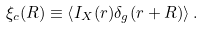Convert formula to latex. <formula><loc_0><loc_0><loc_500><loc_500>\xi _ { c } ( R ) \equiv \left < I _ { X } ( r ) \delta _ { g } ( r + R ) \right > .</formula> 